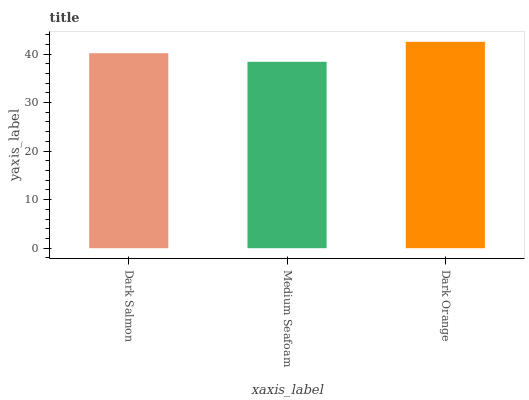Is Medium Seafoam the minimum?
Answer yes or no. Yes. Is Dark Orange the maximum?
Answer yes or no. Yes. Is Dark Orange the minimum?
Answer yes or no. No. Is Medium Seafoam the maximum?
Answer yes or no. No. Is Dark Orange greater than Medium Seafoam?
Answer yes or no. Yes. Is Medium Seafoam less than Dark Orange?
Answer yes or no. Yes. Is Medium Seafoam greater than Dark Orange?
Answer yes or no. No. Is Dark Orange less than Medium Seafoam?
Answer yes or no. No. Is Dark Salmon the high median?
Answer yes or no. Yes. Is Dark Salmon the low median?
Answer yes or no. Yes. Is Dark Orange the high median?
Answer yes or no. No. Is Dark Orange the low median?
Answer yes or no. No. 